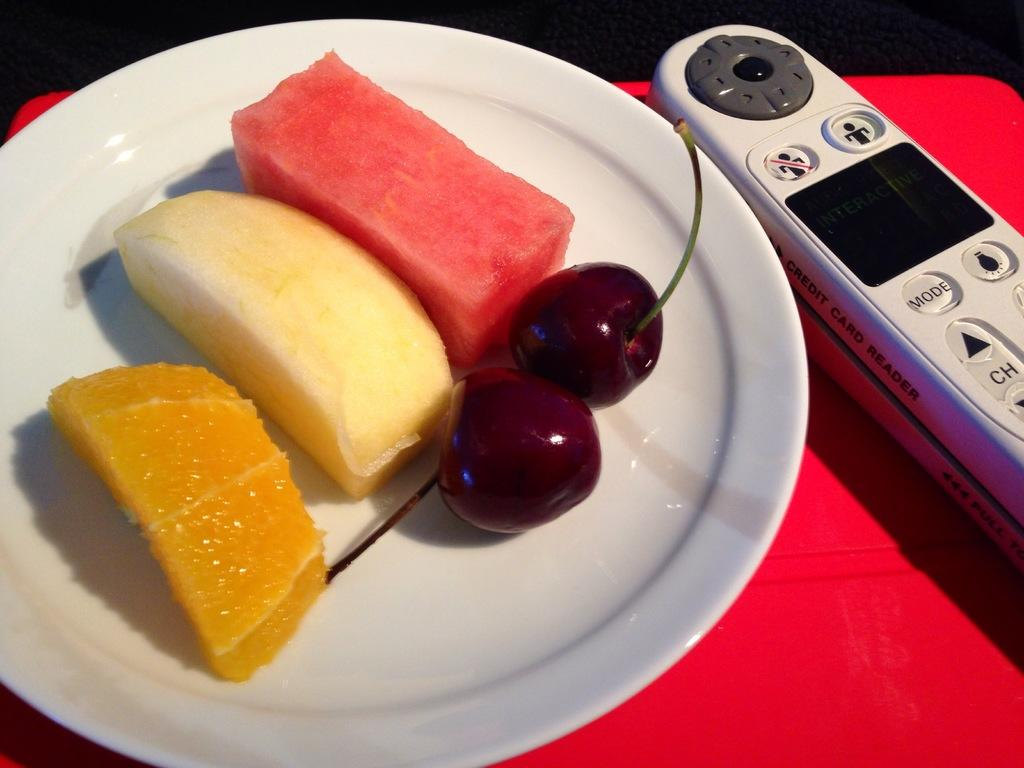<image>
Share a concise interpretation of the image provided. A plate of fruit on a dining table with a remote next to it that displays a "MODE" button. 